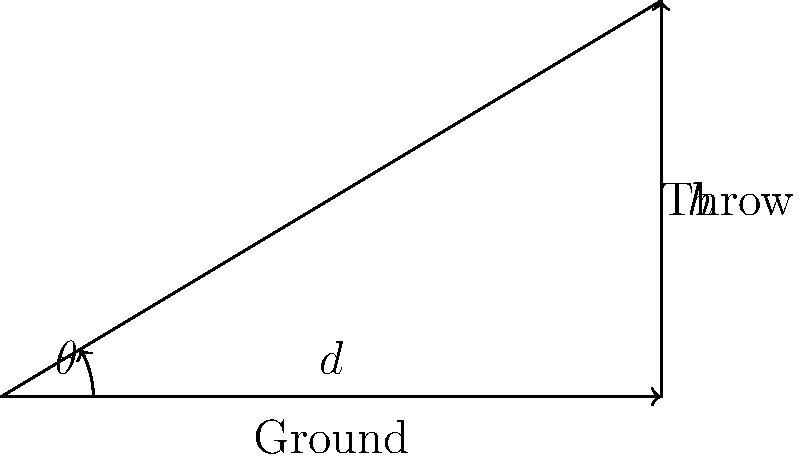As an outfielder for LSU, you need to make a long throw to home plate. The distance to home plate is $d = 200$ feet, and you release the ball at a height of $h = 6$ feet. Assuming no air resistance, what is the optimal angle $\theta$ (in degrees) for the throw to minimize the time it takes for the ball to reach home plate? To find the optimal angle for the throw, we'll follow these steps:

1) The time of flight for a projectile is given by:

   $$t = \frac{2v_0 \sin(\theta)}{g}$$

   where $v_0$ is the initial velocity, $\theta$ is the launch angle, and $g$ is the acceleration due to gravity.

2) The range of the projectile is given by:

   $$R = \frac{v_0^2}{g} \sin(2\theta) + h\cot(\theta)$$

   where $h$ is the initial height.

3) We want to minimize $t$ while ensuring $R = d = 200$ feet.

4) The optimal angle for a projectile launched from ground level is 45°. However, since we're launching from a height, the optimal angle will be slightly less than 45°.

5) The exact solution requires solving a complex equation. However, we can use an approximation:

   $$\theta_{optimal} \approx 45° - \frac{1}{2}\arctan(\frac{4h}{d})$$

6) Plugging in our values:

   $$\theta_{optimal} \approx 45° - \frac{1}{2}\arctan(\frac{4 * 6}{200})$$

7) Calculating:

   $$\theta_{optimal} \approx 45° - \frac{1}{2}\arctan(0.12)$$
   $$\theta_{optimal} \approx 45° - \frac{1}{2} * 6.84°$$
   $$\theta_{optimal} \approx 45° - 3.42°$$
   $$\theta_{optimal} \approx 41.58°$$

Therefore, the optimal angle for the throw is approximately 41.58°.
Answer: 41.58° 